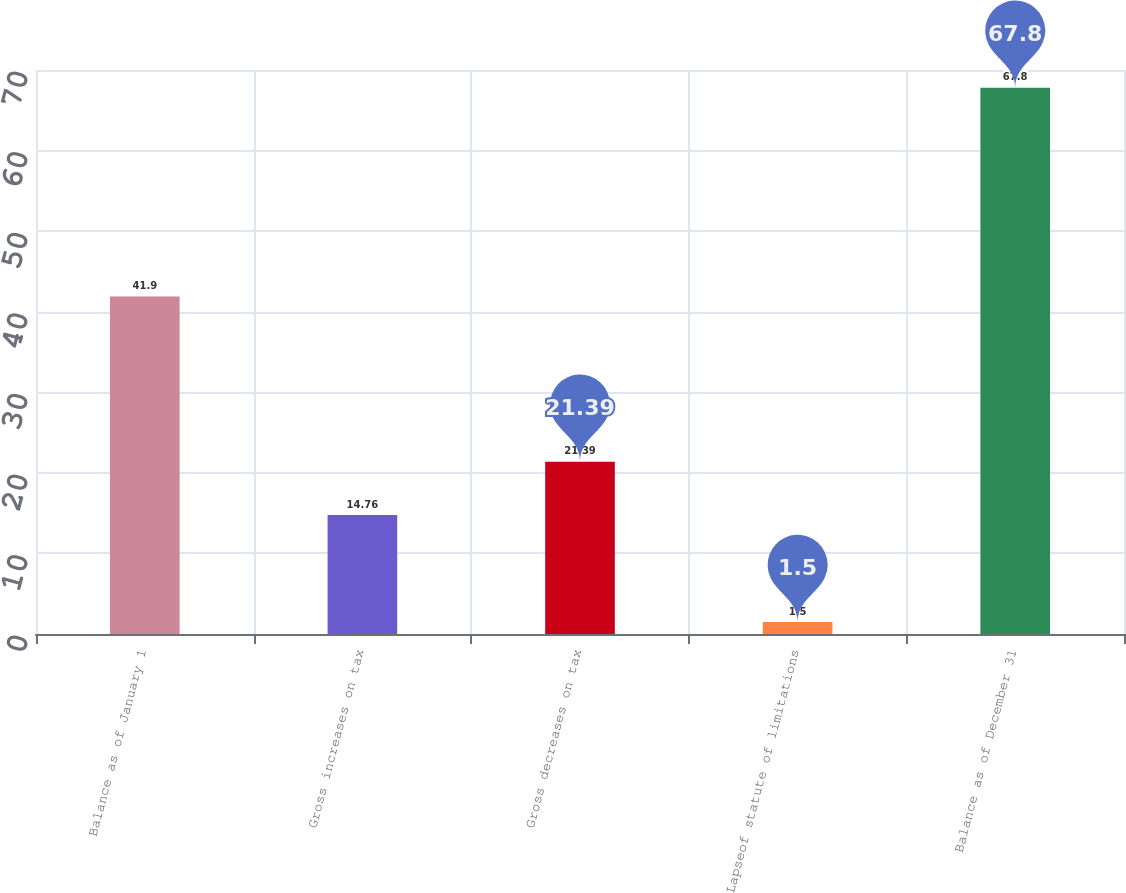<chart> <loc_0><loc_0><loc_500><loc_500><bar_chart><fcel>Balance as of January 1<fcel>Gross increases on tax<fcel>Gross decreases on tax<fcel>Lapseof statute of limitations<fcel>Balance as of December 31<nl><fcel>41.9<fcel>14.76<fcel>21.39<fcel>1.5<fcel>67.8<nl></chart> 